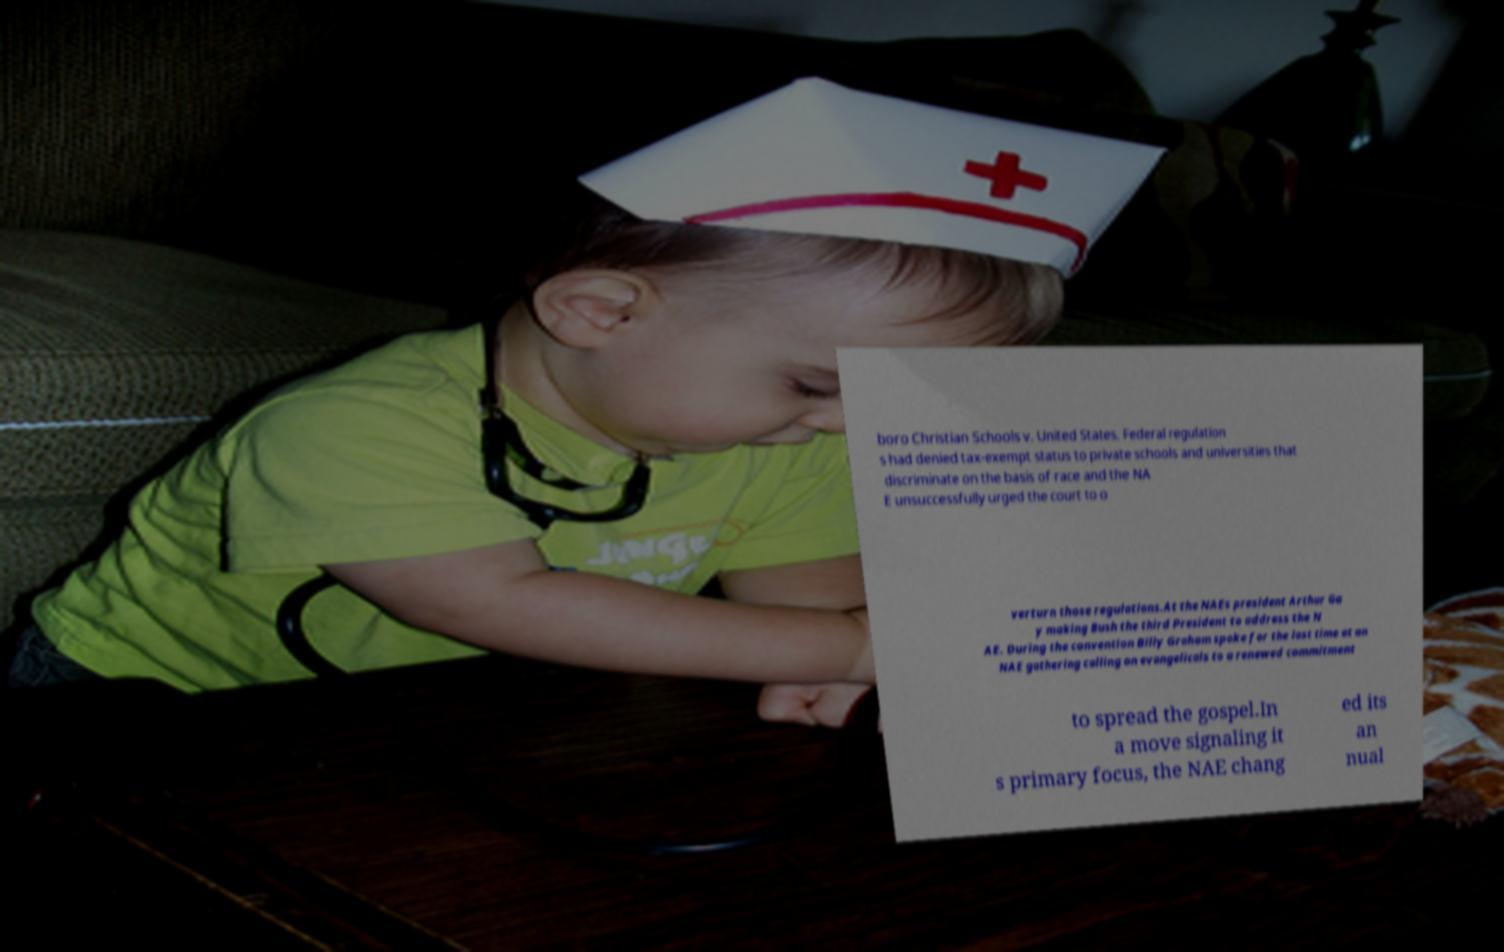Could you assist in decoding the text presented in this image and type it out clearly? boro Christian Schools v. United States. Federal regulation s had denied tax-exempt status to private schools and universities that discriminate on the basis of race and the NA E unsuccessfully urged the court to o verturn those regulations.At the NAEs president Arthur Ga y making Bush the third President to address the N AE. During the convention Billy Graham spoke for the last time at an NAE gathering calling on evangelicals to a renewed commitment to spread the gospel.In a move signaling it s primary focus, the NAE chang ed its an nual 